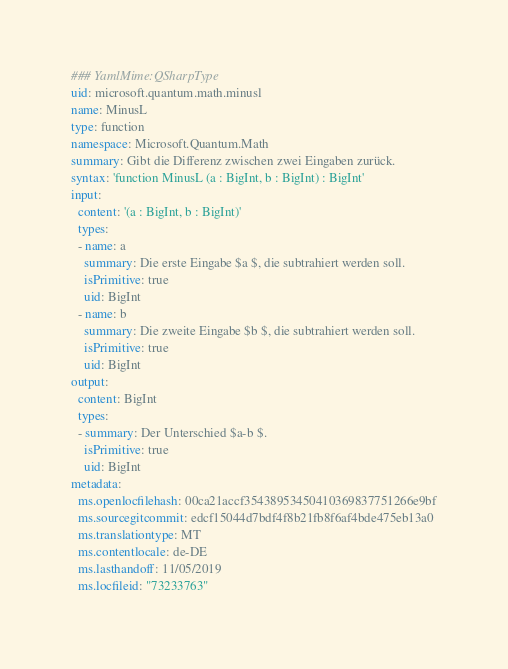Convert code to text. <code><loc_0><loc_0><loc_500><loc_500><_YAML_>### YamlMime:QSharpType
uid: microsoft.quantum.math.minusl
name: MinusL
type: function
namespace: Microsoft.Quantum.Math
summary: Gibt die Differenz zwischen zwei Eingaben zurück.
syntax: 'function MinusL (a : BigInt, b : BigInt) : BigInt'
input:
  content: '(a : BigInt, b : BigInt)'
  types:
  - name: a
    summary: Die erste Eingabe $a $, die subtrahiert werden soll.
    isPrimitive: true
    uid: BigInt
  - name: b
    summary: Die zweite Eingabe $b $, die subtrahiert werden soll.
    isPrimitive: true
    uid: BigInt
output:
  content: BigInt
  types:
  - summary: Der Unterschied $a-b $.
    isPrimitive: true
    uid: BigInt
metadata:
  ms.openlocfilehash: 00ca21accf35438953450410369837751266e9bf
  ms.sourcegitcommit: edcf15044d7bdf4f8b21fb8f6af4bde475eb13a0
  ms.translationtype: MT
  ms.contentlocale: de-DE
  ms.lasthandoff: 11/05/2019
  ms.locfileid: "73233763"
</code> 